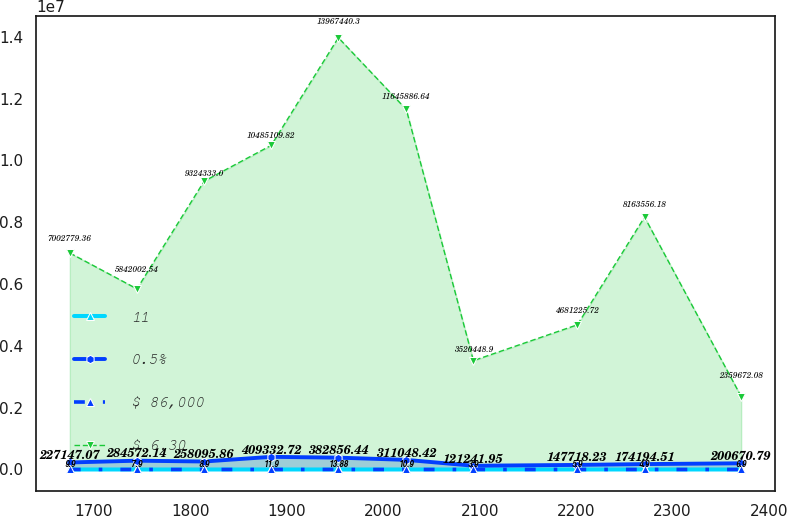<chart> <loc_0><loc_0><loc_500><loc_500><line_chart><ecel><fcel>11<fcel>0.5%<fcel>$ 86,000<fcel>$ 6.30<nl><fcel>1675.11<fcel>25.21<fcel>227147<fcel>9.9<fcel>7.00278e+06<nl><fcel>1744.7<fcel>23.18<fcel>284572<fcel>7.9<fcel>5.842e+06<nl><fcel>1814.29<fcel>28.07<fcel>258096<fcel>8.9<fcel>9.32433e+06<nl><fcel>1883.88<fcel>15.06<fcel>409333<fcel>11.9<fcel>1.04851e+07<nl><fcel>1953.47<fcel>21.15<fcel>382856<fcel>13.88<fcel>1.39674e+07<nl><fcel>2023.85<fcel>17.09<fcel>311048<fcel>10.9<fcel>1.16459e+07<nl><fcel>2093.44<fcel>13.03<fcel>121242<fcel>3.9<fcel>3.52045e+06<nl><fcel>2201.24<fcel>11<fcel>147718<fcel>5.9<fcel>4.68123e+06<nl><fcel>2270.83<fcel>19.12<fcel>174195<fcel>4.9<fcel>8.16356e+06<nl><fcel>2371<fcel>7.76<fcel>200671<fcel>6.9<fcel>2.35967e+06<nl></chart> 